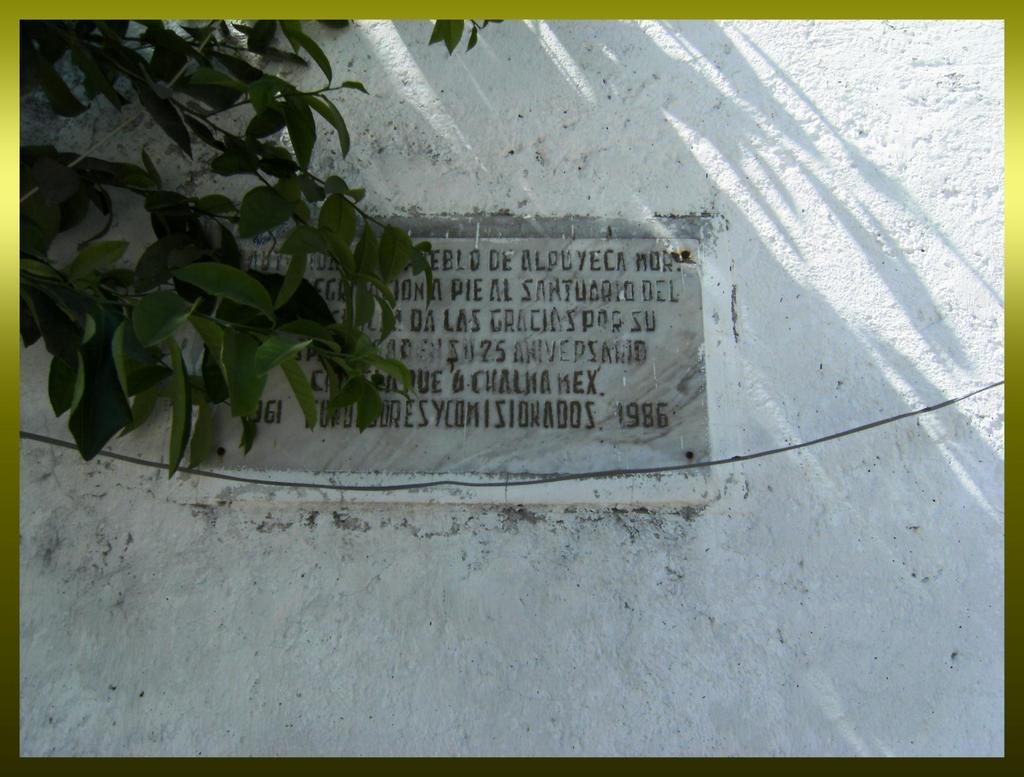What is present in the image that serves as a background or barrier? There is a wall in the image. What can be seen in the middle of the image? Something is written in the middle of the image. What type of vegetation is visible on the left side of the image? There are leaves visible on the left side of the image. What type of zinc is present in the image? There is no zinc present in the image. How does the fuel affect the leaves on the left side of the image? There is no fuel present in the image, and therefore it cannot affect the leaves. 